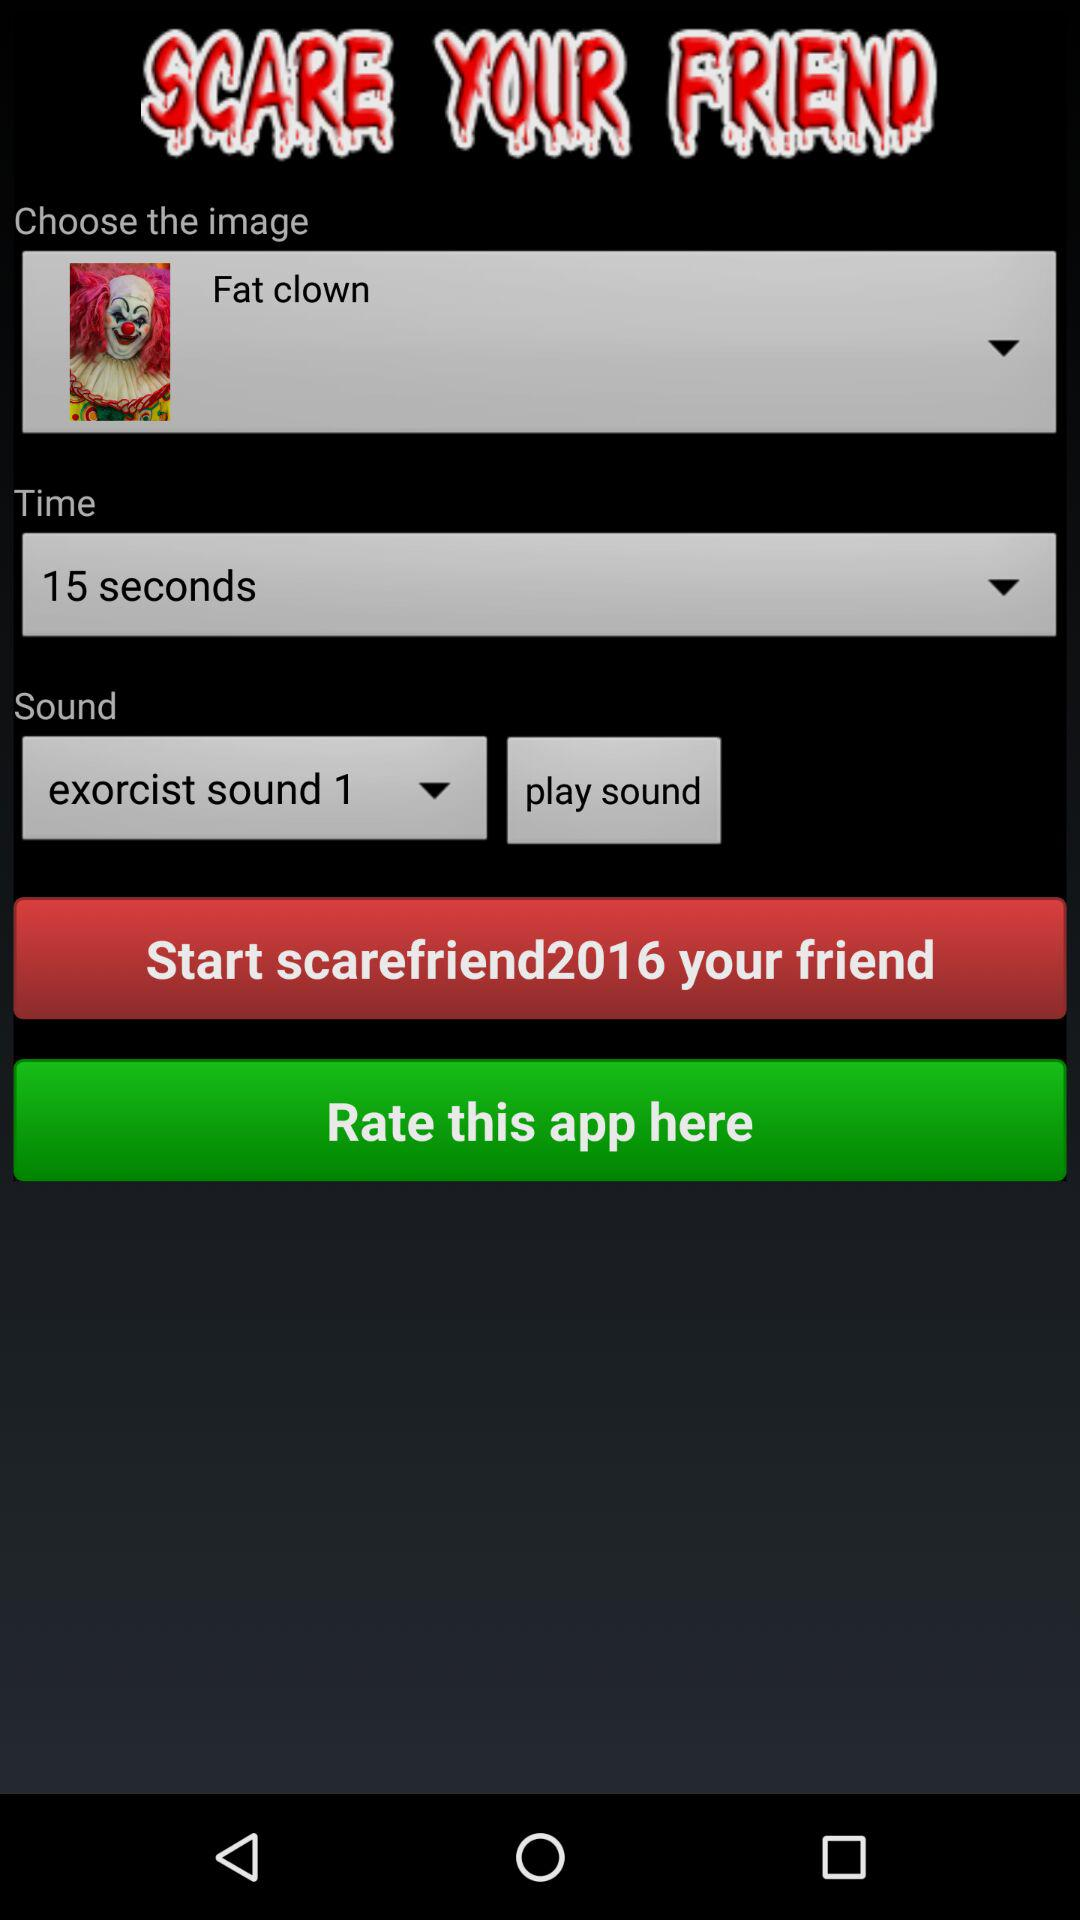What is the selected time? The selected time is 15 seconds. 